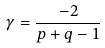<formula> <loc_0><loc_0><loc_500><loc_500>\gamma = \frac { - 2 } { p + q - 1 } \</formula> 